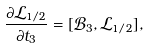Convert formula to latex. <formula><loc_0><loc_0><loc_500><loc_500>\frac { \partial \mathcal { L } _ { 1 / 2 } } { \partial t _ { 3 } } = [ \mathcal { B } _ { 3 } , \mathcal { L } _ { 1 / 2 } ] ,</formula> 